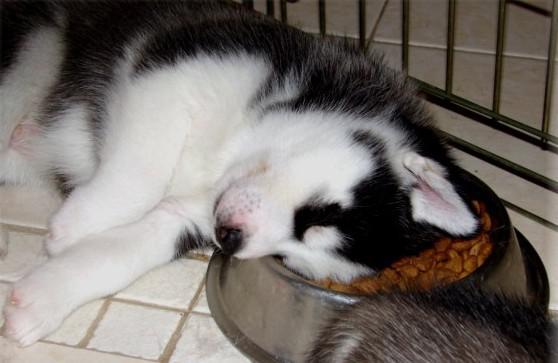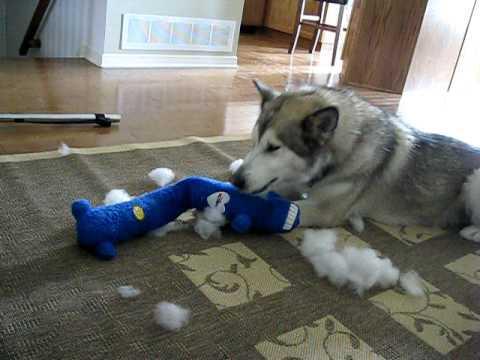The first image is the image on the left, the second image is the image on the right. For the images shown, is this caption "A dog can be seen interacting with a severed limb portion of another animal." true? Answer yes or no. No. The first image is the image on the left, the second image is the image on the right. Examine the images to the left and right. Is the description "Each image shows a single husky dog, and one of the dogs pictured is in a reclining pose with its muzzle over a pinkish 'bone' and at least one paw near the object." accurate? Answer yes or no. No. 